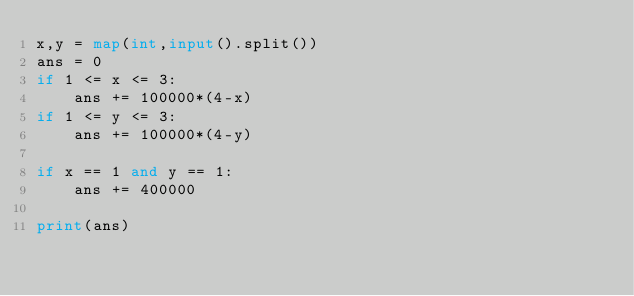Convert code to text. <code><loc_0><loc_0><loc_500><loc_500><_Python_>x,y = map(int,input().split())
ans = 0
if 1 <= x <= 3:
    ans += 100000*(4-x)
if 1 <= y <= 3:
    ans += 100000*(4-y)

if x == 1 and y == 1:
    ans += 400000

print(ans)
</code> 